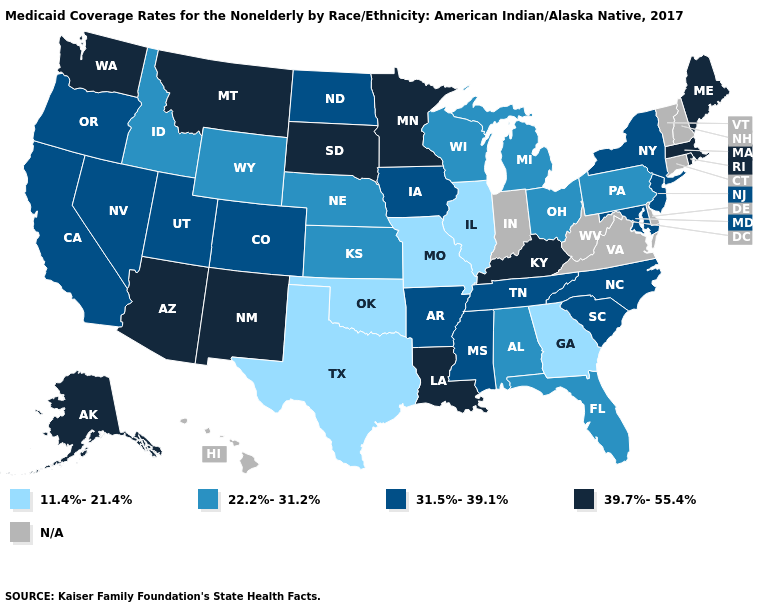What is the value of Utah?
Give a very brief answer. 31.5%-39.1%. What is the value of Wyoming?
Be succinct. 22.2%-31.2%. Name the states that have a value in the range N/A?
Be succinct. Connecticut, Delaware, Hawaii, Indiana, New Hampshire, Vermont, Virginia, West Virginia. Which states have the lowest value in the USA?
Short answer required. Georgia, Illinois, Missouri, Oklahoma, Texas. What is the value of Idaho?
Be succinct. 22.2%-31.2%. Which states have the lowest value in the USA?
Keep it brief. Georgia, Illinois, Missouri, Oklahoma, Texas. Which states have the highest value in the USA?
Quick response, please. Alaska, Arizona, Kentucky, Louisiana, Maine, Massachusetts, Minnesota, Montana, New Mexico, Rhode Island, South Dakota, Washington. Name the states that have a value in the range 22.2%-31.2%?
Give a very brief answer. Alabama, Florida, Idaho, Kansas, Michigan, Nebraska, Ohio, Pennsylvania, Wisconsin, Wyoming. What is the value of Maryland?
Keep it brief. 31.5%-39.1%. Name the states that have a value in the range 39.7%-55.4%?
Be succinct. Alaska, Arizona, Kentucky, Louisiana, Maine, Massachusetts, Minnesota, Montana, New Mexico, Rhode Island, South Dakota, Washington. Does Minnesota have the lowest value in the USA?
Be succinct. No. What is the lowest value in states that border Massachusetts?
Write a very short answer. 31.5%-39.1%. What is the value of Mississippi?
Short answer required. 31.5%-39.1%. Does New York have the highest value in the Northeast?
Answer briefly. No. 